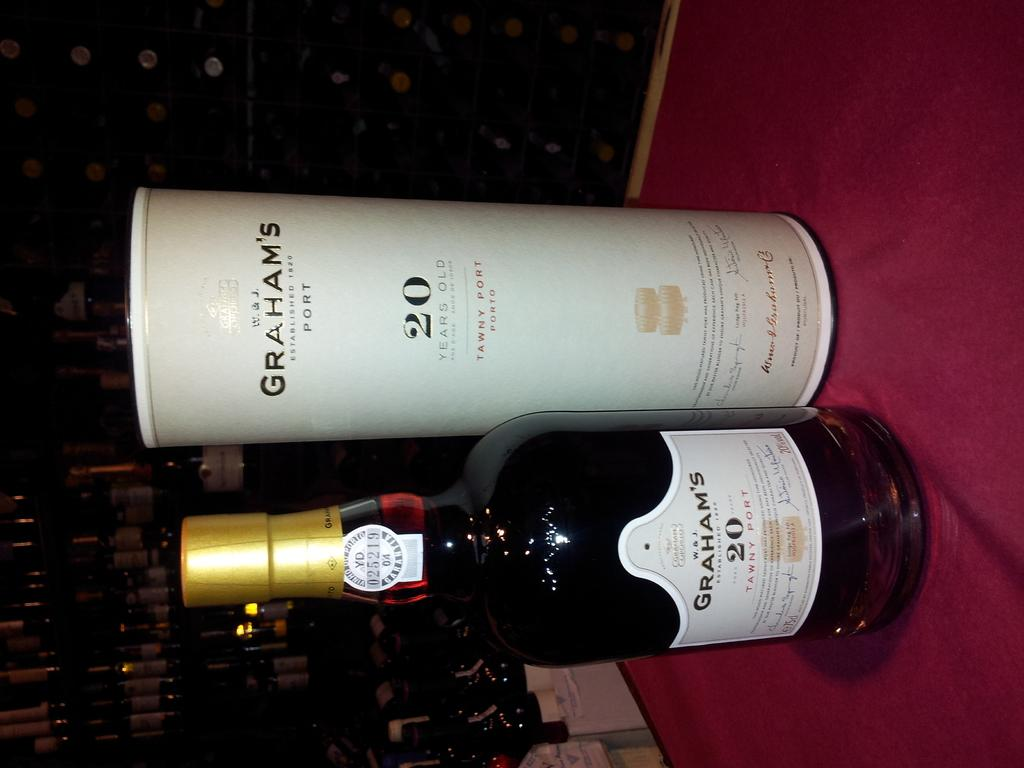Provide a one-sentence caption for the provided image. A bottle of Graham's 20 tawny port sits on a red cloth. 